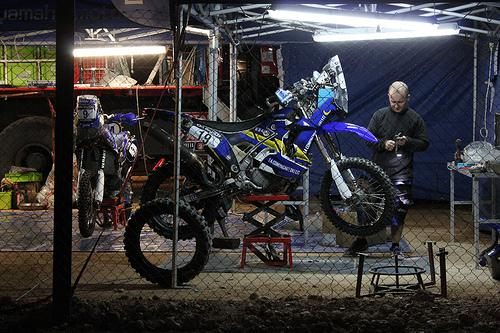Question: where is the man?
Choices:
A. At work.
B. In a bike shop.
C. In the car.
D. At home.
Answer with the letter. Answer: B Question: how many bikes you see?
Choices:
A. About three.
B. 2.
C. 1.
D. 4.
Answer with the letter. Answer: A Question: why is the man out there?
Choices:
A. Mowing the lawn.
B. Eating dinner.
C. Working.
D. Talking to friends.
Answer with the letter. Answer: C Question: what is above the man head?
Choices:
A. A picture.
B. A fan.
C. The ceiling.
D. Some lights.
Answer with the letter. Answer: D Question: what kind of bikes are these?
Choices:
A. Dirt bikes.
B. Mountain bikes.
C. Motor bikes.
D. Street bikes.
Answer with the letter. Answer: A 